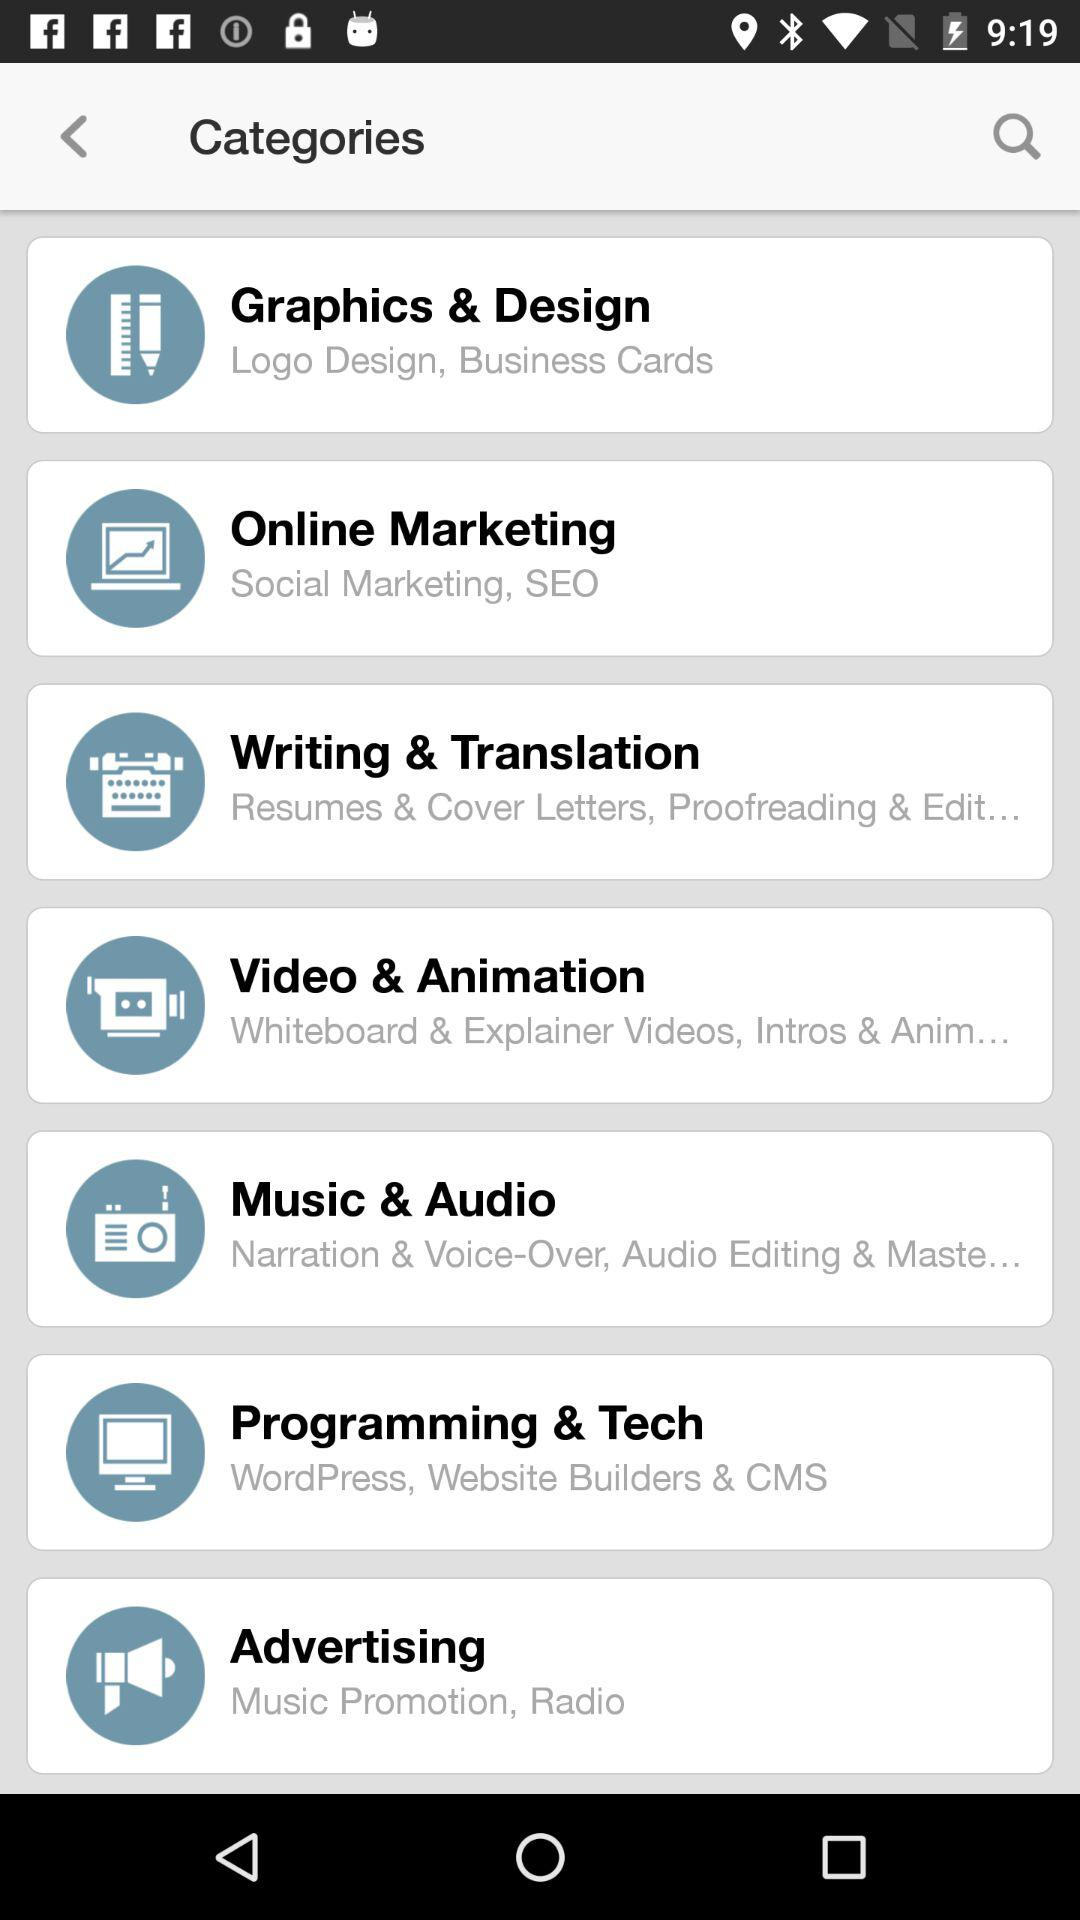What is the definition of Programming & Tech?
When the provided information is insufficient, respond with <no answer>. <no answer> 